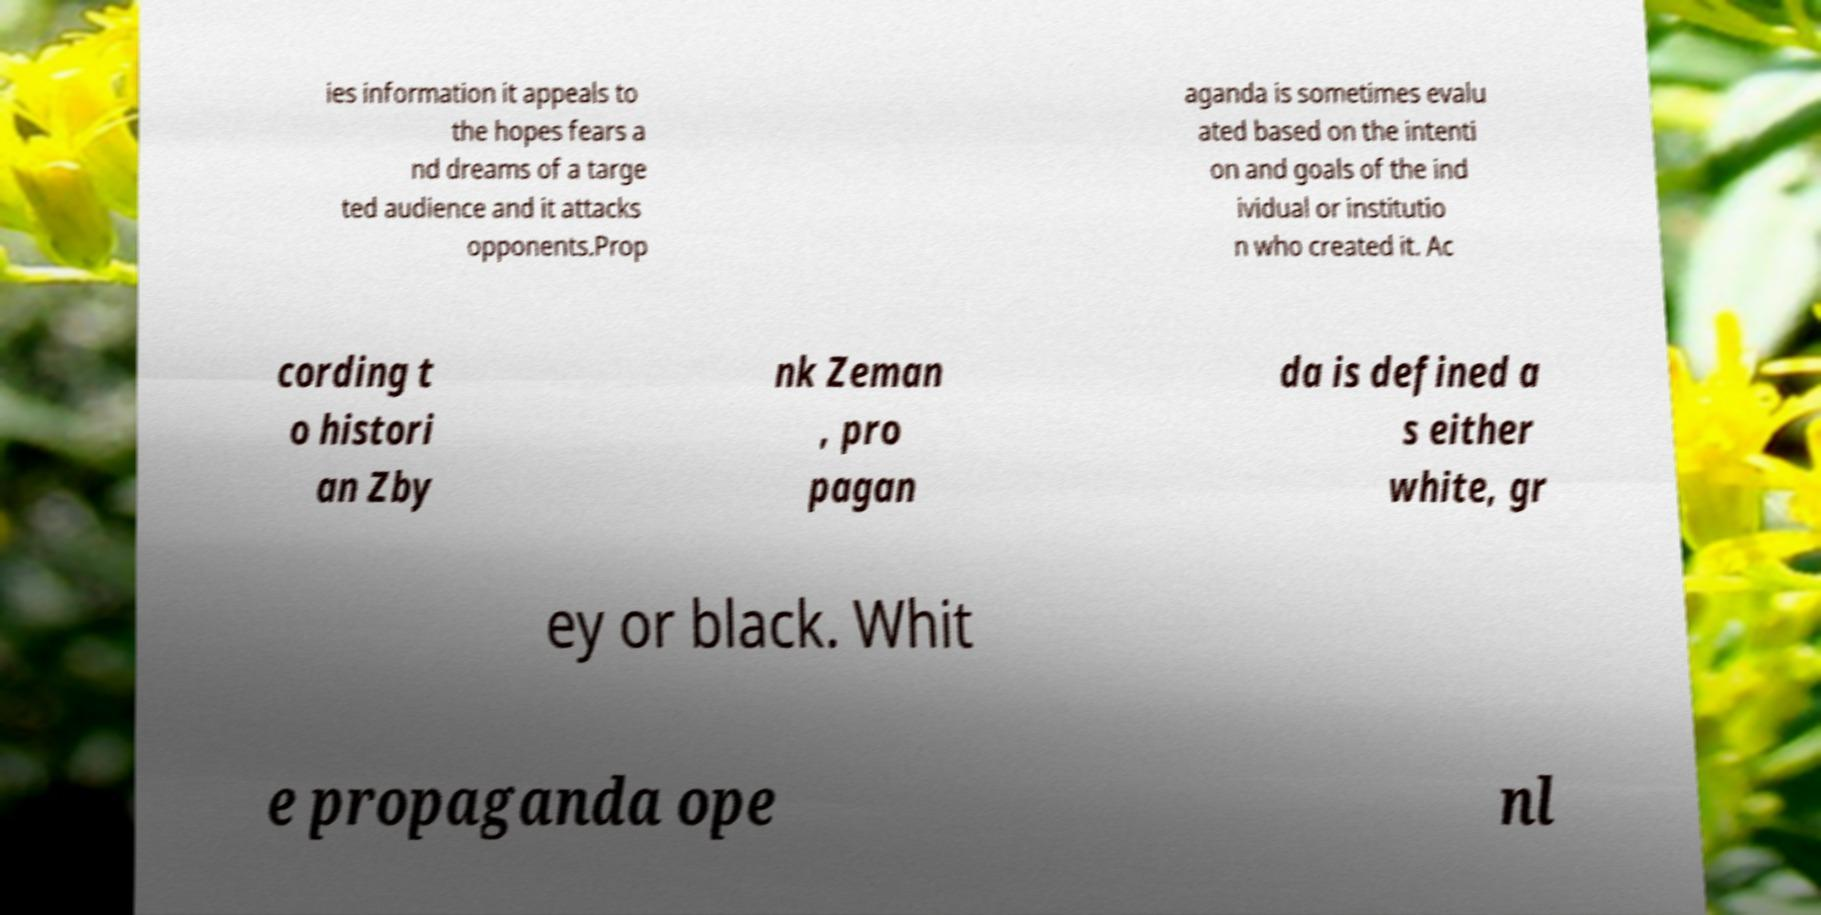I need the written content from this picture converted into text. Can you do that? ies information it appeals to the hopes fears a nd dreams of a targe ted audience and it attacks opponents.Prop aganda is sometimes evalu ated based on the intenti on and goals of the ind ividual or institutio n who created it. Ac cording t o histori an Zby nk Zeman , pro pagan da is defined a s either white, gr ey or black. Whit e propaganda ope nl 